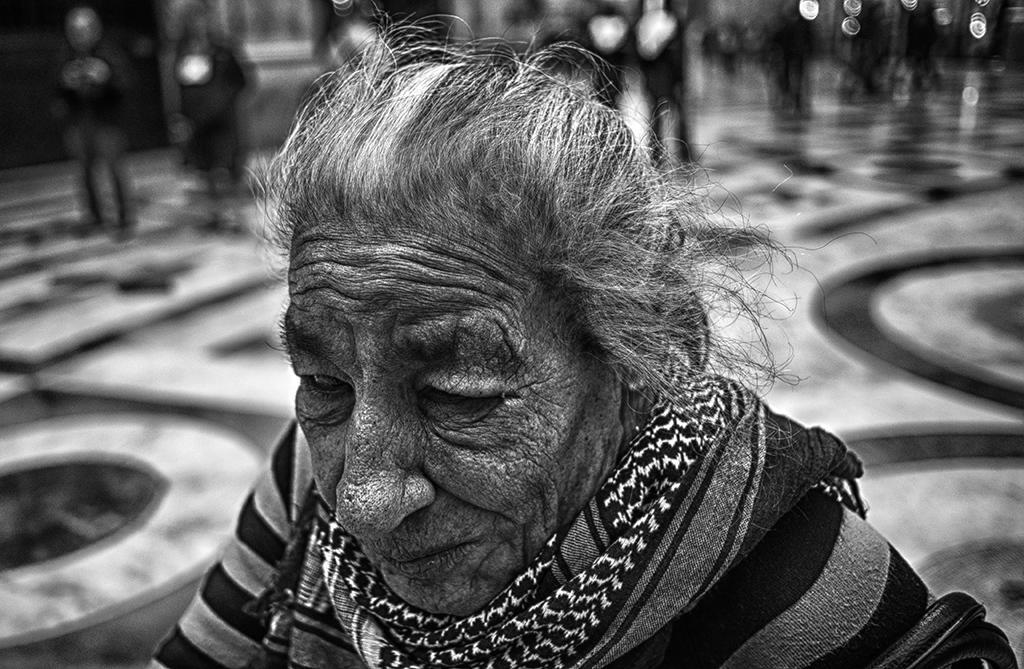How would you summarize this image in a sentence or two? In the image we can see there is an old woman and she is wearing scarf around her neck. Behind there are people standing and the background is blurred. 